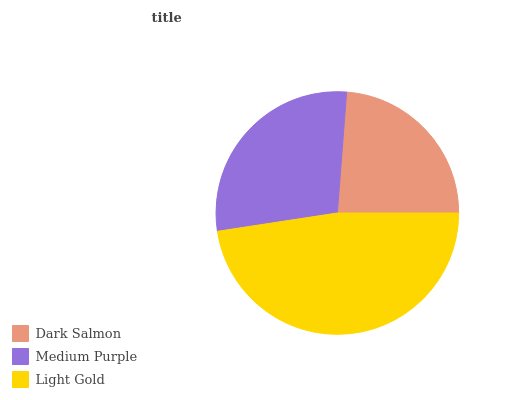Is Dark Salmon the minimum?
Answer yes or no. Yes. Is Light Gold the maximum?
Answer yes or no. Yes. Is Medium Purple the minimum?
Answer yes or no. No. Is Medium Purple the maximum?
Answer yes or no. No. Is Medium Purple greater than Dark Salmon?
Answer yes or no. Yes. Is Dark Salmon less than Medium Purple?
Answer yes or no. Yes. Is Dark Salmon greater than Medium Purple?
Answer yes or no. No. Is Medium Purple less than Dark Salmon?
Answer yes or no. No. Is Medium Purple the high median?
Answer yes or no. Yes. Is Medium Purple the low median?
Answer yes or no. Yes. Is Light Gold the high median?
Answer yes or no. No. Is Light Gold the low median?
Answer yes or no. No. 